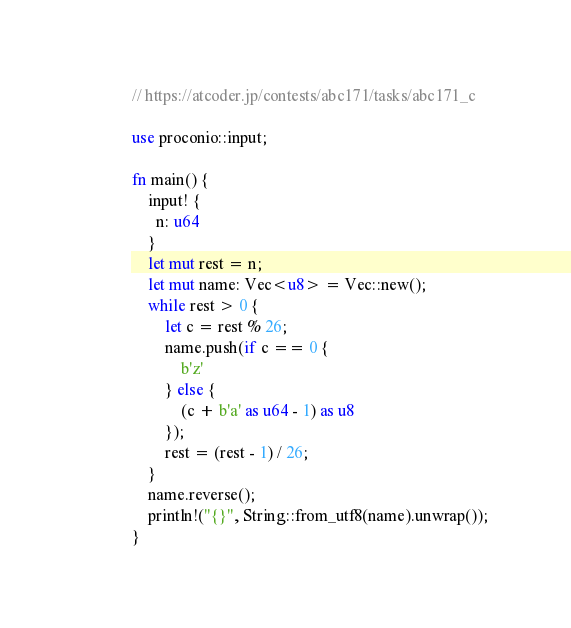Convert code to text. <code><loc_0><loc_0><loc_500><loc_500><_Rust_>// https://atcoder.jp/contests/abc171/tasks/abc171_c

use proconio::input;

fn main() {
    input! {
      n: u64
    }
    let mut rest = n;
    let mut name: Vec<u8> = Vec::new();
    while rest > 0 {
        let c = rest % 26;
        name.push(if c == 0 {
            b'z'
        } else {
            (c + b'a' as u64 - 1) as u8
        });
        rest = (rest - 1) / 26;
    }
    name.reverse();
    println!("{}", String::from_utf8(name).unwrap());
}
</code> 